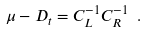Convert formula to latex. <formula><loc_0><loc_0><loc_500><loc_500>\mu - D _ { t } = C _ { L } ^ { - 1 } C _ { R } ^ { - 1 } \ .</formula> 